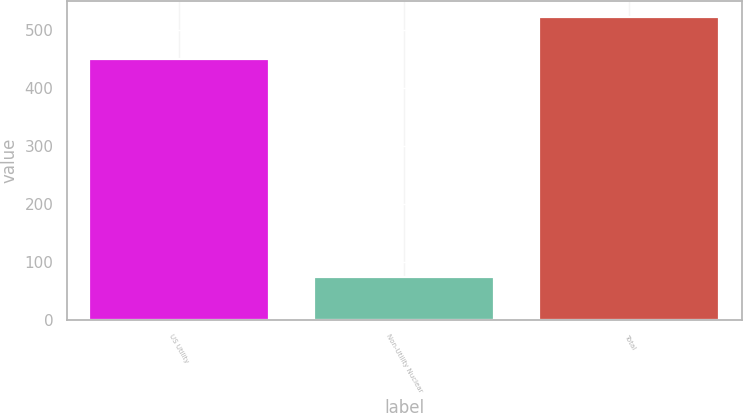<chart> <loc_0><loc_0><loc_500><loc_500><bar_chart><fcel>US Utility<fcel>Non-Utility Nuclear<fcel>Total<nl><fcel>450<fcel>74<fcel>524<nl></chart> 